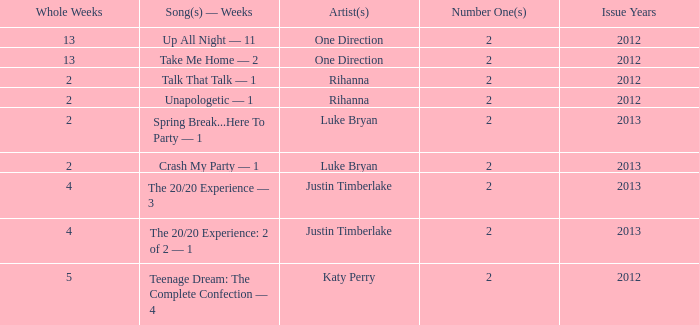What is the title of every song, and how many weeks was each song at #1 for Rihanna in 2012? Talk That Talk — 1, Unapologetic — 1. 